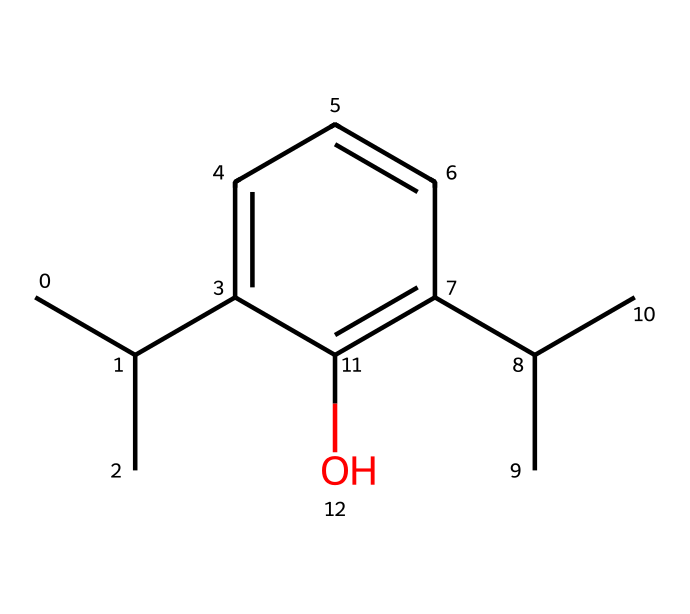What is the base structure of this chemical? The base structure appears to be a phenolic compound due to the presence of the aromatic ring (c1cccc) and a hydroxyl group (O) attached to it.
Answer: phenolic compound How many carbon atoms are present in this molecule? By analyzing the SMILES representation, we can count the carbon atoms, which total to 15 (CC(C) contributes 3, c1cccc contributes 5, and 2 C(C) contributions add 4 more).
Answer: 15 What functional group is present in this chemical? The hydroxyl group (-OH) attached to the aromatic ring indicates the presence of a phenolic functional group, which classifies it as a phenol.
Answer: hydroxyl group Is this chemical likely to be hydrophilic or hydrophobic? The presence of the hydroxyl group suggests that the compound is hydrophilic, while the large hydrocarbon part (C(C)C) may introduce hydrophobic properties. Since phenols are generally more polar, overall, it leans towards hydrophilic.
Answer: hydrophilic What type of reaction could this chemical most likely undergo? Its structure, particularly the hydroxyl group, makes it suitable for electrophilic aromatic substitution reactions, where the aromatic ring can undergo substitution reactions due to its stability and the presence of activating groups.
Answer: electrophilic aromatic substitution 